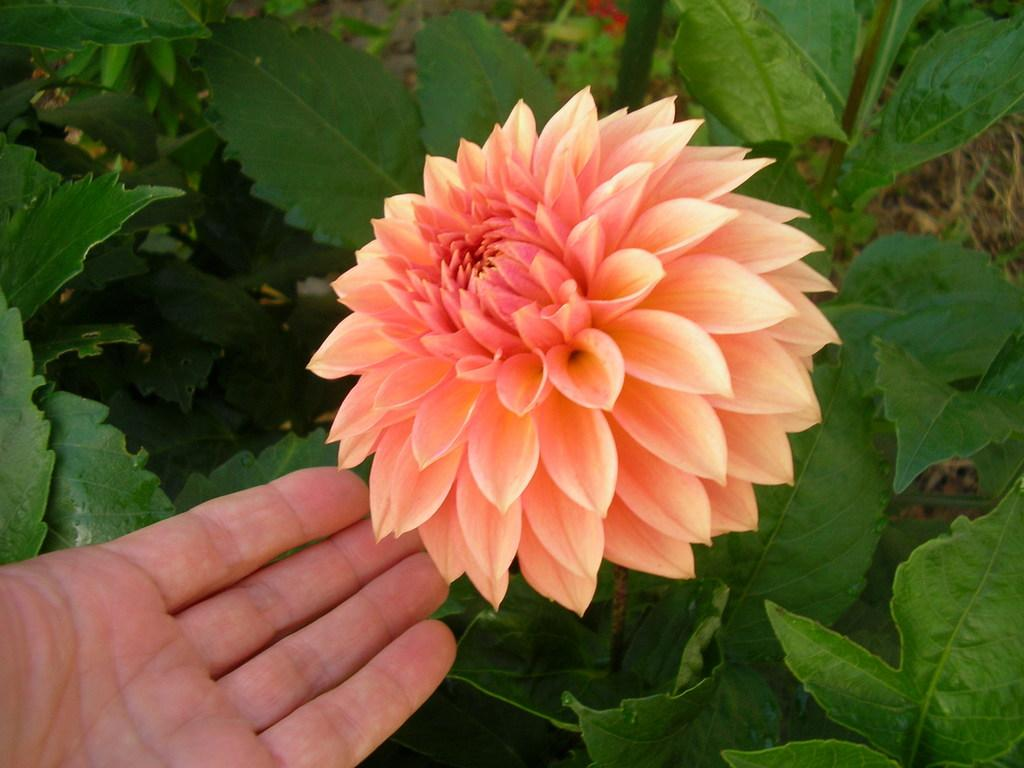What type of plant is visible in the image? There is a flower on a plant in the image. Can you describe any other elements in the image? A human hand is visible in the image. What type of soda is being poured into the picture in the image? There is no soda or picture present in the image; it only features a flower on a plant and a human hand. 